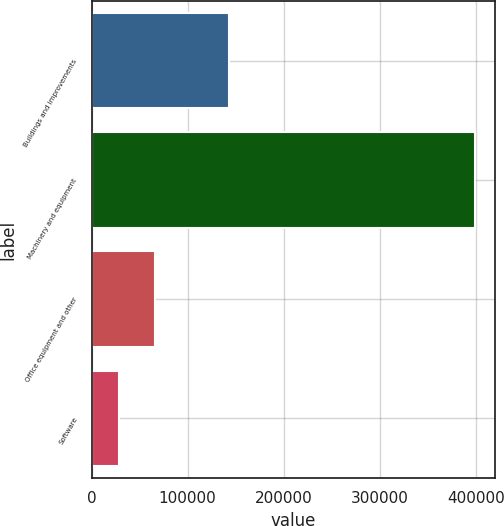Convert chart. <chart><loc_0><loc_0><loc_500><loc_500><bar_chart><fcel>Buildings and improvements<fcel>Machinery and equipment<fcel>Office equipment and other<fcel>Software<nl><fcel>143503<fcel>399730<fcel>65604.1<fcel>28479<nl></chart> 